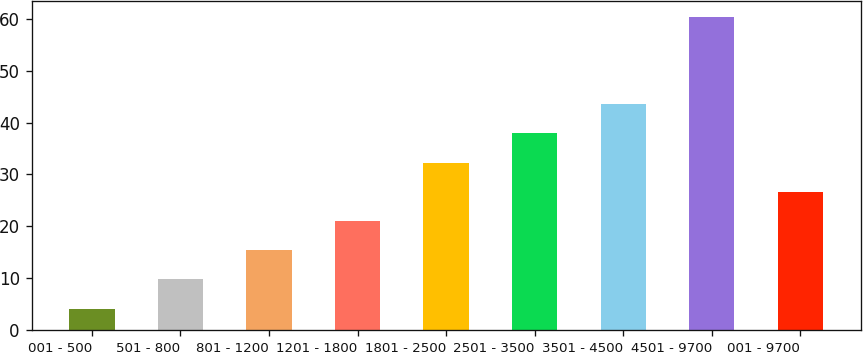Convert chart to OTSL. <chart><loc_0><loc_0><loc_500><loc_500><bar_chart><fcel>001 - 500<fcel>501 - 800<fcel>801 - 1200<fcel>1201 - 1800<fcel>1801 - 2500<fcel>2501 - 3500<fcel>3501 - 4500<fcel>4501 - 9700<fcel>001 - 9700<nl><fcel>4.09<fcel>9.73<fcel>15.37<fcel>21.01<fcel>32.29<fcel>37.93<fcel>43.57<fcel>60.5<fcel>26.65<nl></chart> 